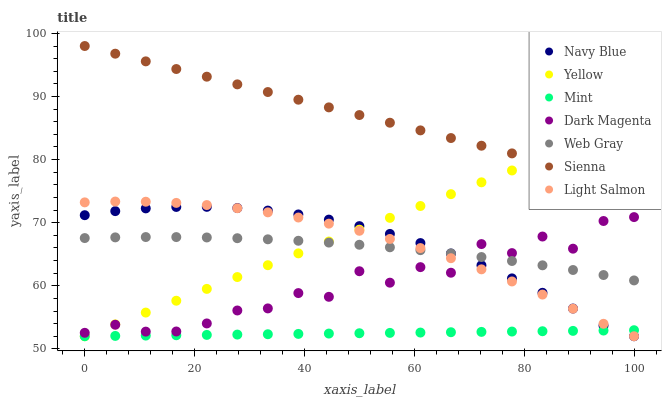Does Mint have the minimum area under the curve?
Answer yes or no. Yes. Does Sienna have the maximum area under the curve?
Answer yes or no. Yes. Does Web Gray have the minimum area under the curve?
Answer yes or no. No. Does Web Gray have the maximum area under the curve?
Answer yes or no. No. Is Mint the smoothest?
Answer yes or no. Yes. Is Dark Magenta the roughest?
Answer yes or no. Yes. Is Web Gray the smoothest?
Answer yes or no. No. Is Web Gray the roughest?
Answer yes or no. No. Does Light Salmon have the lowest value?
Answer yes or no. Yes. Does Web Gray have the lowest value?
Answer yes or no. No. Does Sienna have the highest value?
Answer yes or no. Yes. Does Web Gray have the highest value?
Answer yes or no. No. Is Dark Magenta less than Sienna?
Answer yes or no. Yes. Is Sienna greater than Light Salmon?
Answer yes or no. Yes. Does Dark Magenta intersect Navy Blue?
Answer yes or no. Yes. Is Dark Magenta less than Navy Blue?
Answer yes or no. No. Is Dark Magenta greater than Navy Blue?
Answer yes or no. No. Does Dark Magenta intersect Sienna?
Answer yes or no. No. 